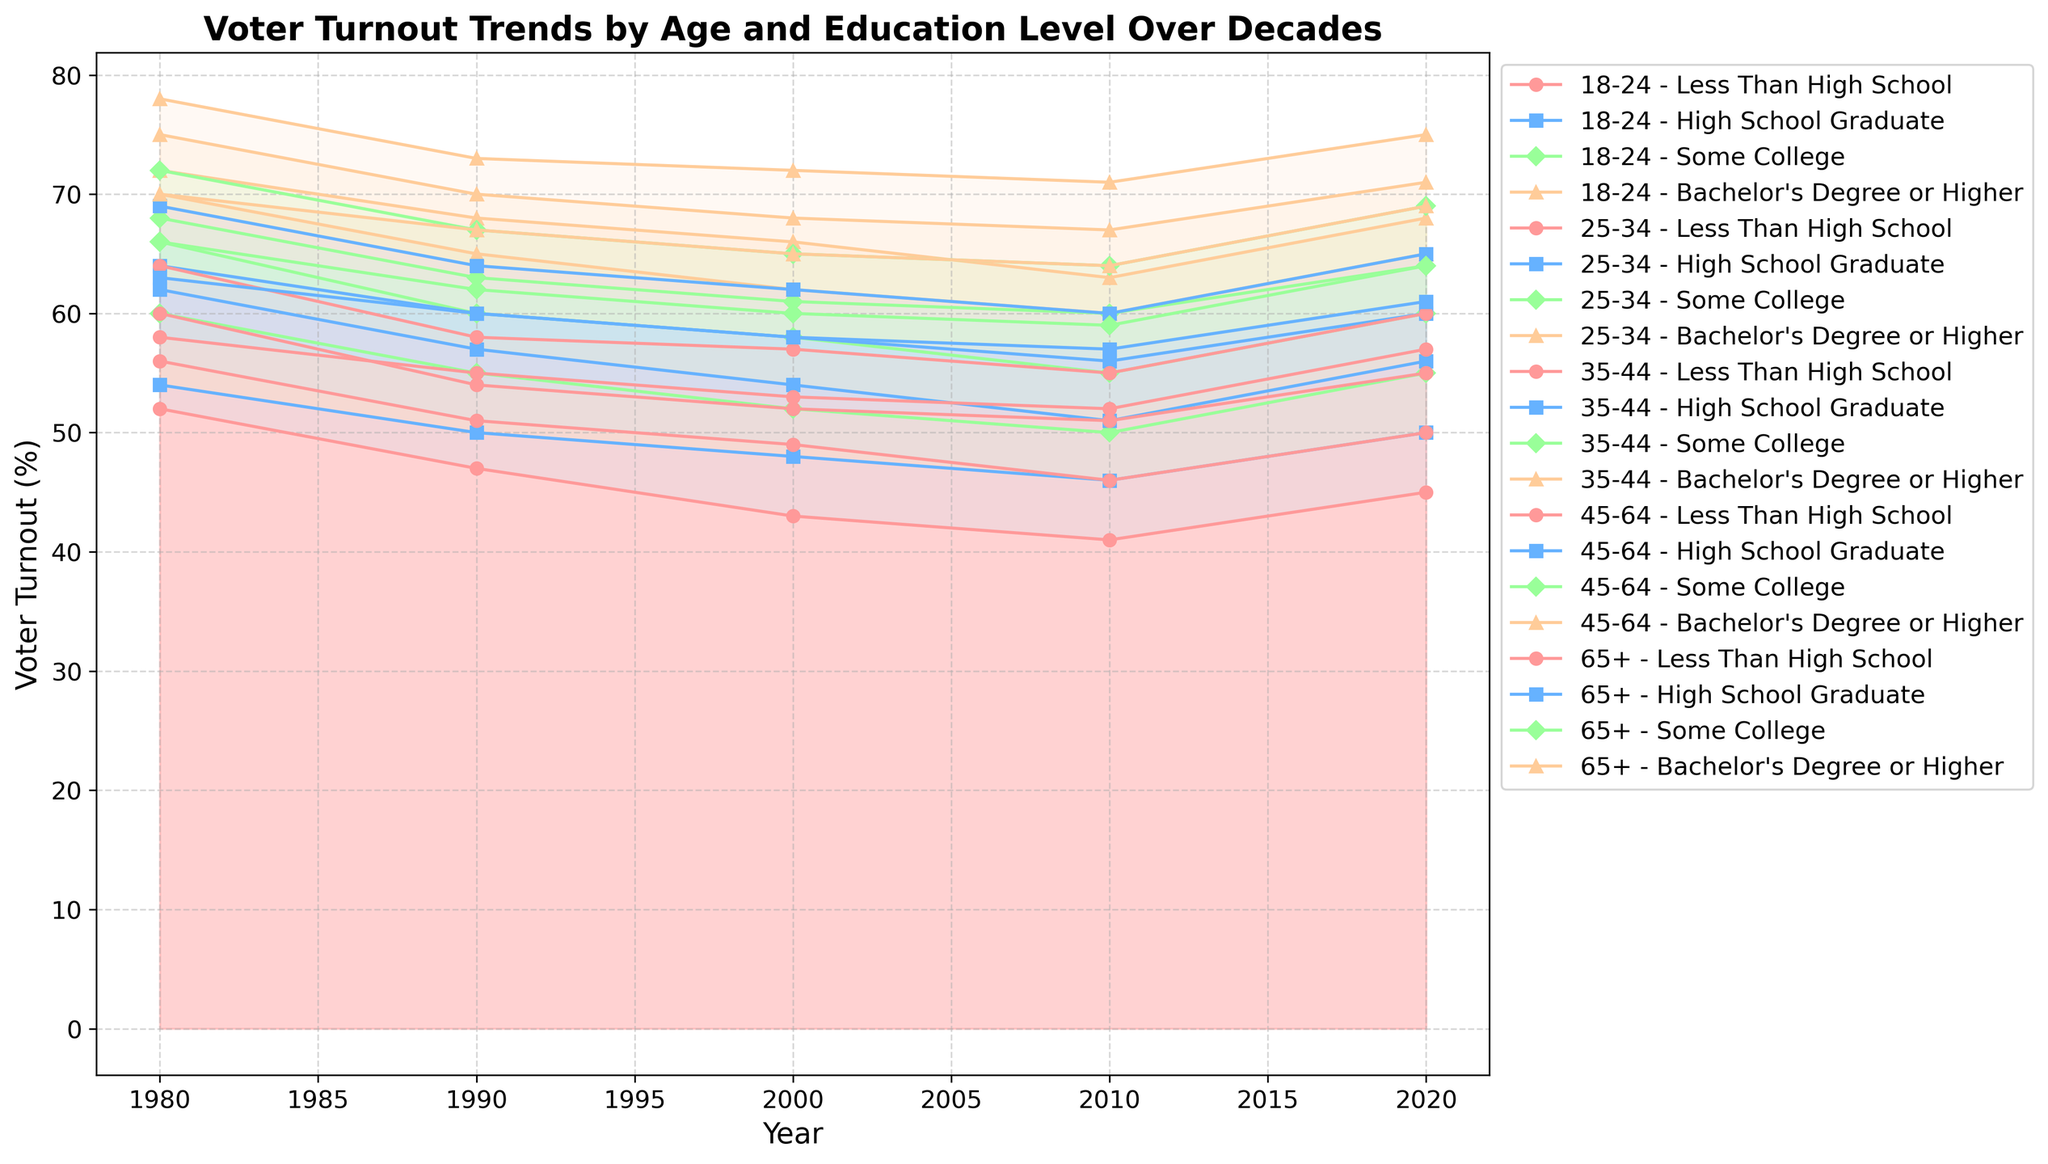What age group had the highest voter turnout in 2020 for individuals with Bachelor's Degree or higher? To determine this, look at the voter turnout lines in 2020 for each age group and see which one has the highest starting value for the Bachelor's Degree or higher. The 45-64 age group had a turnout of 75%.
Answer: 45-64 What was the difference in voter turnout between the 18-24 and 65+ age groups with less than a high school degree in 1980? In 1980, the 18-24 age group had a voter turnout of 52%, and the 65+ age group had a turnout of 58%. The difference is 58% - 52% = 6%.
Answer: 6% How did the voter turnout for the 25-34 age group with Some College change from 1990 to 2000? In 1990, the turnout was 60%. By 2000, it dropped to 58%. The change is 58% - 60% = -2%. This indicates a decrease.
Answer: Decreased by 2% Which education group shows a consistent decrease in voter turnout from 1980 to 2010 for the 18-24 age group? To find this, check the lines for each education group within the 18-24 age group from 1980 to 2010. Both 'Less Than High School' and 'High School Graduate' show consistent decreases over the years.
Answer: Less Than High School, High School Graduate What are the average voter turnouts for Bachelor's Degree or higher across all age groups in 1990? To find the average, sum the voter turnouts for Bachelor's Degree or higher in 1990 across all age groups (65% + 68% + 70% + 73% + 67%) and divide by the number of age groups (5). (65 + 68 + 70 + 73 + 67) / 5 = 68.6%.
Answer: 68.6% Between the 25-34 and 35-44 age groups with a High School Graduate education in 2020, which had a higher voter turnout? Compare the turnout lines in 2020 for both age groups. The 35-44 age group shows 60%, while the 25-34 age group shows 56%. Thus, the 35-44 age group had a higher turnout.
Answer: 35-44 Did the voter turnout for the 45-64 age group with Bachelor's Degree or higher increase or decrease from 2000 to 2010, and by how much? Look at the values for the 45-64 age group with Bachelor's Degree or higher for the years 2000 and 2010. It was 72% in 2000 and 71% in 2010, resulting in a decrease of 1%.
Answer: Decreased by 1% Which age group showed the lowest voter turnout for individuals with Some College in 2010? Identify the values for Some College education in each age group for the year 2010. The 18-24 age group had the lowest turnout rate of 50%.
Answer: 18-24 What is the combined increase in voter turnout for the 65+ age group with a High School Graduate education from 1980 to 2020? The turnout in 1980 was 63%, increasing to 61% in 2020. Although the value shows a decrease, interpret the nuances; it decreased by 2%, which might appear as a combined reduction.
Answer: Decreased by 2% 